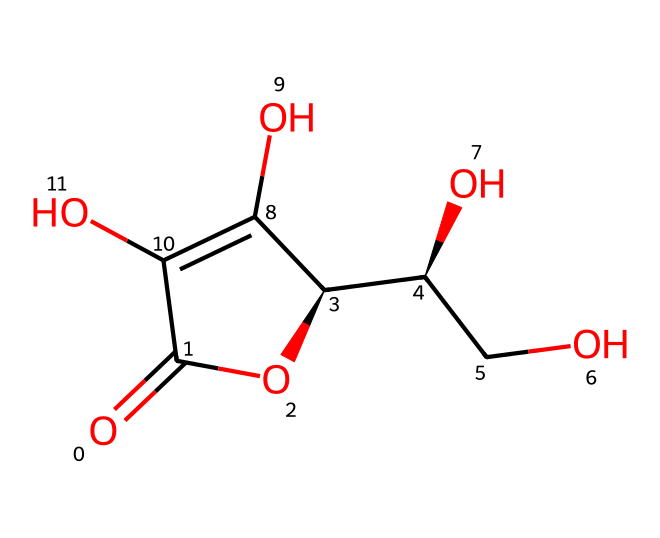What is the common name for this chemical? The chemical structure corresponds to ascorbic acid, which is commonly known as Vitamin C.
Answer: Vitamin C How many carbon atoms are in this chemical? Counting in the structure, there are 6 carbon atoms present in the ascorbic acid molecule.
Answer: 6 What type of functional group is present in ascorbic acid? The structure shows multiple hydroxyl (–OH) groups, which indicates it has alcohol functional groups.
Answer: hydroxyl Is this chemical an antioxidant? Ascorbic acid is well-known for its antioxidant properties, which means it can prevent oxidation of other molecules.
Answer: yes What role does ascorbic acid play in food preservation? Ascorbic acid acts as a natural preservative by inhibiting the growth of certain bacteria and slowing down oxidation, which improves shelf life.
Answer: preservative How many double bonds are present in this chemical? Upon examining the structure, there are 2 double bonds identified in the ascorbic acid molecule.
Answer: 2 What elements are present in ascorbic acid? The structure reveals the presence of carbon (C), hydrogen (H), and oxygen (O) atoms, which are the primary elements making up ascorbic acid.
Answer: carbon, hydrogen, oxygen 